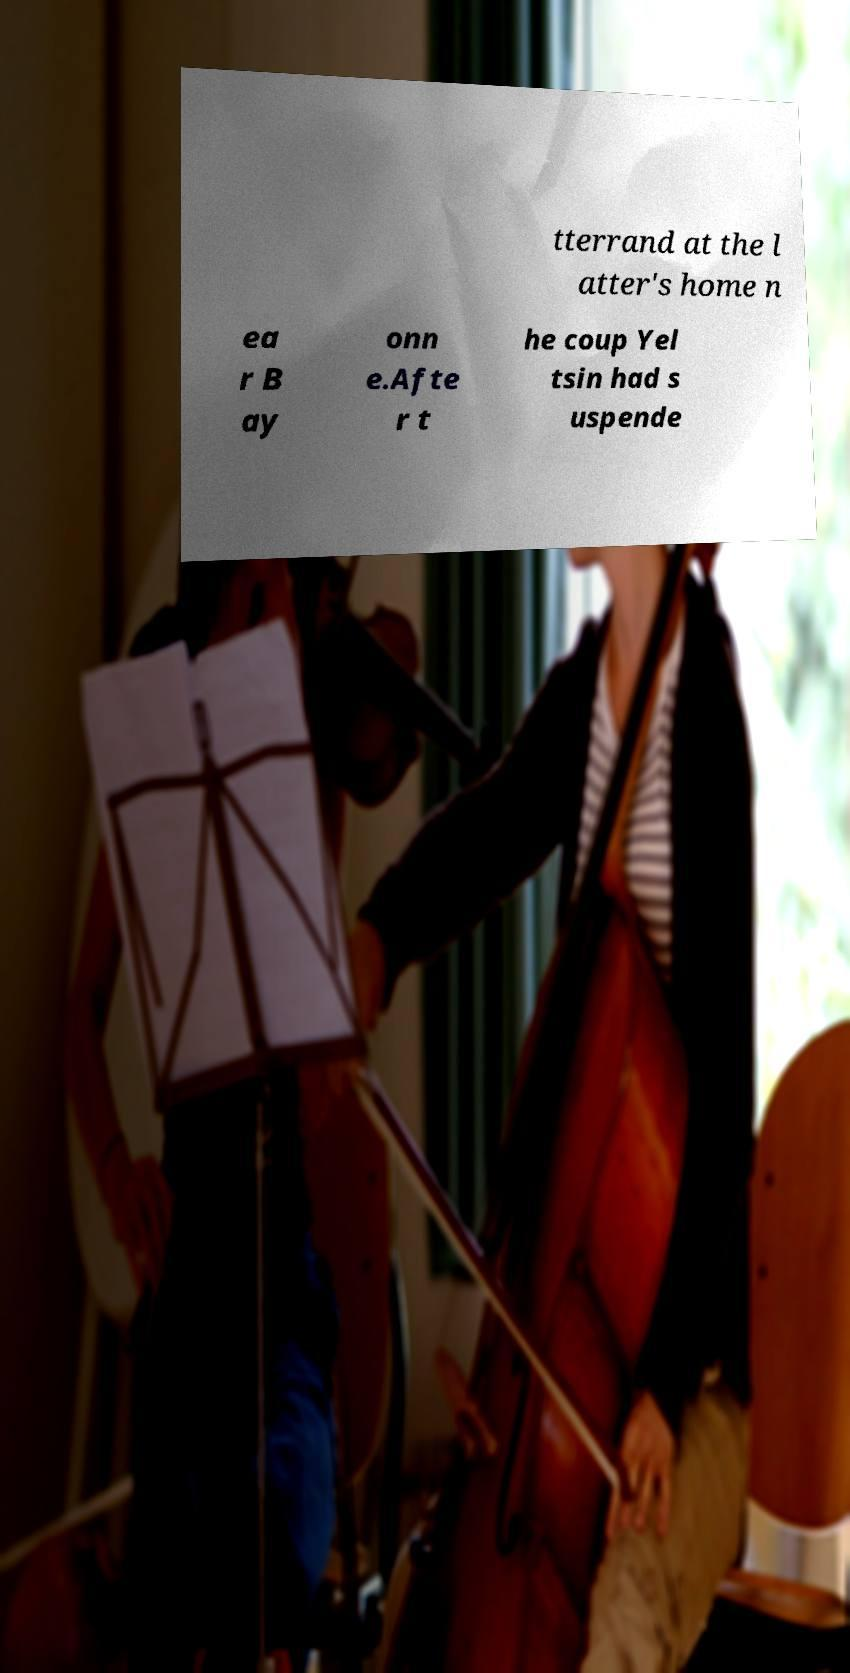Can you accurately transcribe the text from the provided image for me? tterrand at the l atter's home n ea r B ay onn e.Afte r t he coup Yel tsin had s uspende 